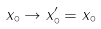Convert formula to latex. <formula><loc_0><loc_0><loc_500><loc_500>x _ { \circ } \rightarrow x ^ { \prime } _ { \circ } = x _ { \circ }</formula> 